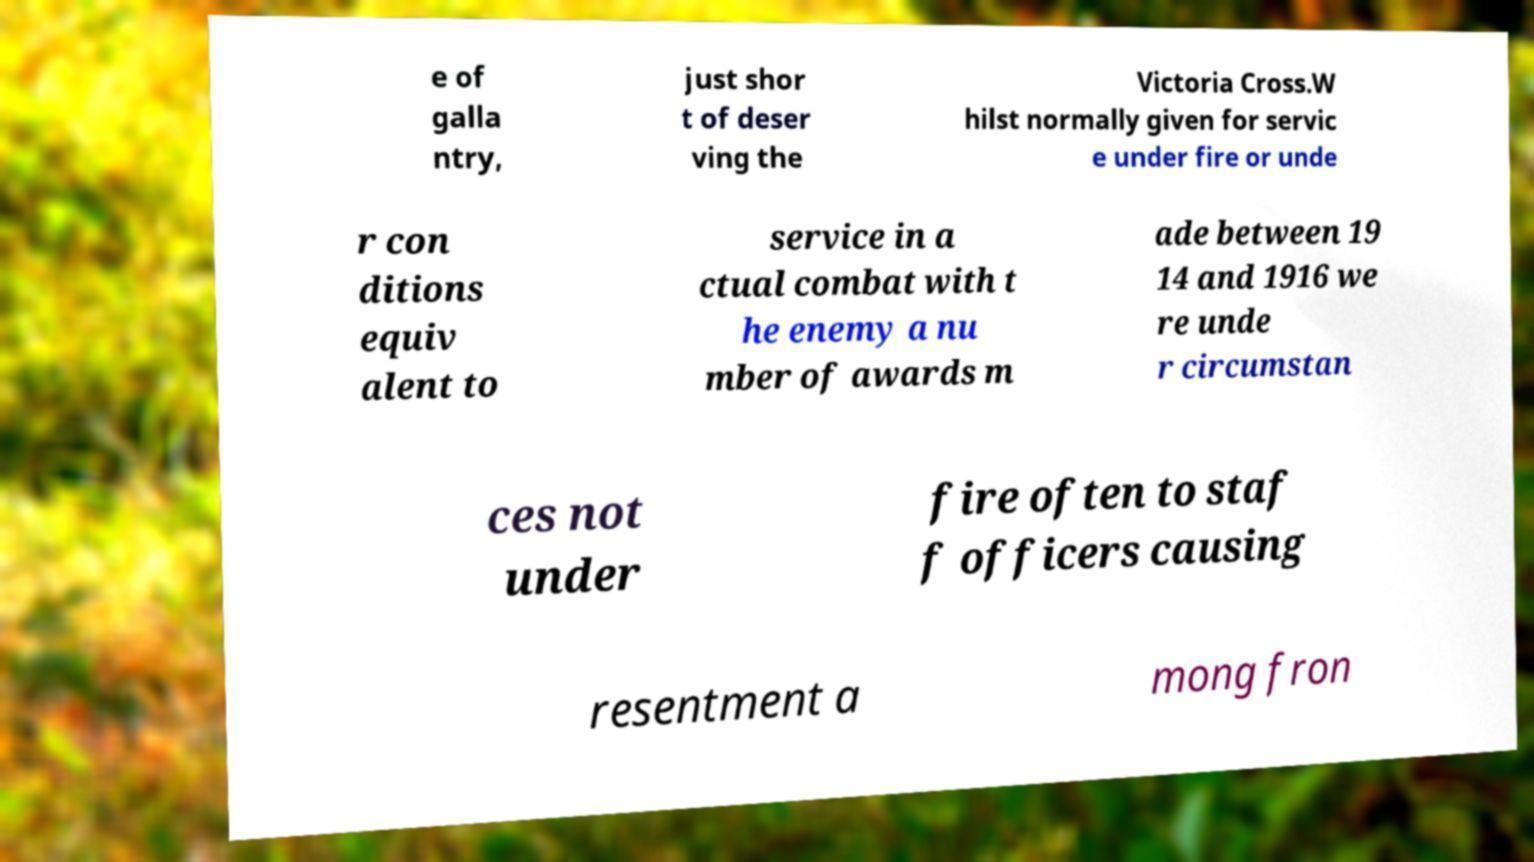Can you accurately transcribe the text from the provided image for me? e of galla ntry, just shor t of deser ving the Victoria Cross.W hilst normally given for servic e under fire or unde r con ditions equiv alent to service in a ctual combat with t he enemy a nu mber of awards m ade between 19 14 and 1916 we re unde r circumstan ces not under fire often to staf f officers causing resentment a mong fron 